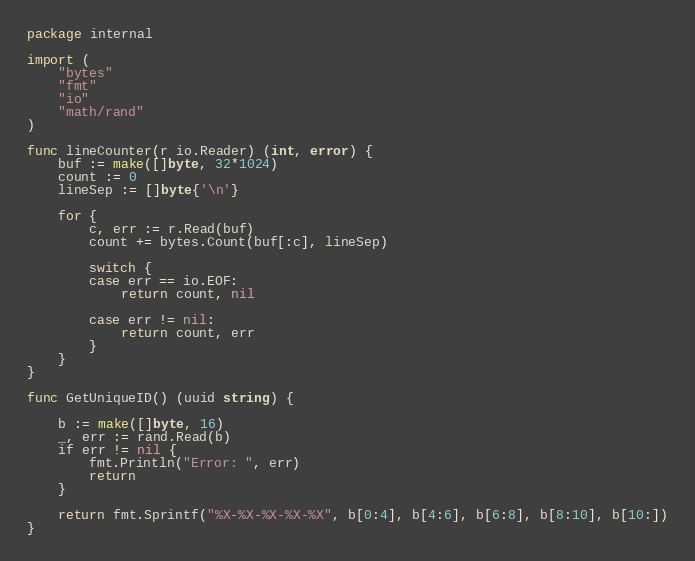Convert code to text. <code><loc_0><loc_0><loc_500><loc_500><_Go_>package internal

import (
	"bytes"
	"fmt"
	"io"
	"math/rand"
)

func lineCounter(r io.Reader) (int, error) {
	buf := make([]byte, 32*1024)
	count := 0
	lineSep := []byte{'\n'}

	for {
		c, err := r.Read(buf)
		count += bytes.Count(buf[:c], lineSep)

		switch {
		case err == io.EOF:
			return count, nil

		case err != nil:
			return count, err
		}
	}
}

func GetUniqueID() (uuid string) {

	b := make([]byte, 16)
	_, err := rand.Read(b)
	if err != nil {
		fmt.Println("Error: ", err)
		return
	}

	return fmt.Sprintf("%X-%X-%X-%X-%X", b[0:4], b[4:6], b[6:8], b[8:10], b[10:])
}</code> 